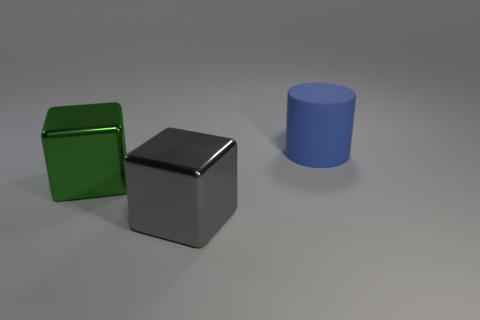There is a object that is behind the shiny cube that is behind the big metal object on the right side of the green block; what color is it?
Ensure brevity in your answer.  Blue. How many rubber objects are large gray objects or big green blocks?
Make the answer very short. 0. Is the green block the same size as the gray block?
Provide a succinct answer. Yes. Is the number of cubes that are to the left of the green metallic block less than the number of big cubes to the right of the cylinder?
Keep it short and to the point. No. Is there any other thing that has the same size as the gray object?
Give a very brief answer. Yes. How big is the green cube?
Keep it short and to the point. Large. What number of small things are either rubber cylinders or green metal cubes?
Ensure brevity in your answer.  0. Do the green metal object and the thing that is on the right side of the big gray object have the same size?
Offer a very short reply. Yes. Is there any other thing that is the same shape as the large blue object?
Keep it short and to the point. No. How many tiny gray cubes are there?
Provide a short and direct response. 0. 